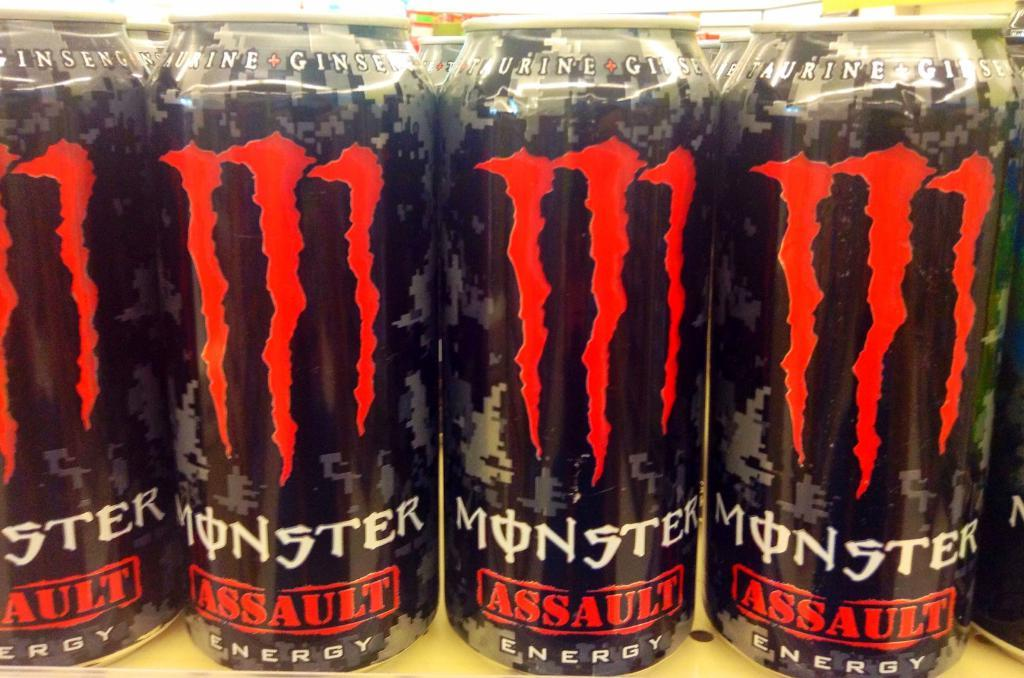<image>
Offer a succinct explanation of the picture presented. A row of energy drinks that say Monster Assault. 